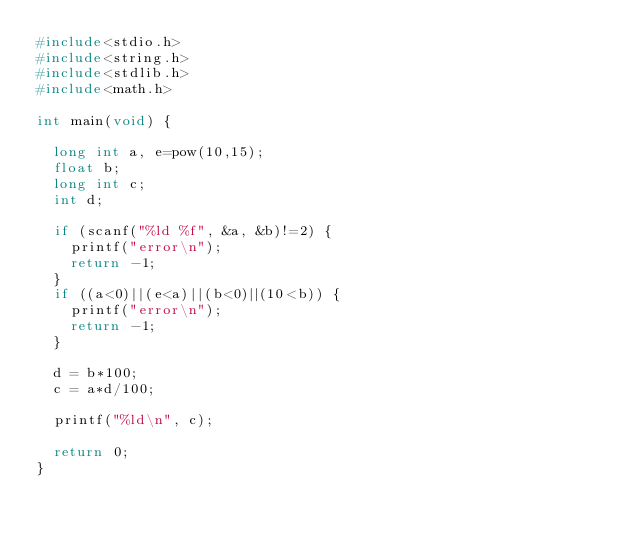Convert code to text. <code><loc_0><loc_0><loc_500><loc_500><_C_>#include<stdio.h>
#include<string.h>
#include<stdlib.h>
#include<math.h>

int main(void) {

  long int a, e=pow(10,15);
  float b;
  long int c;
  int d;

  if (scanf("%ld %f", &a, &b)!=2) {
    printf("error\n");
    return -1;
  }
  if ((a<0)||(e<a)||(b<0)||(10<b)) {
    printf("error\n");
    return -1;
  }

  d = b*100;
  c = a*d/100;

  printf("%ld\n", c);

  return 0;
}
</code> 